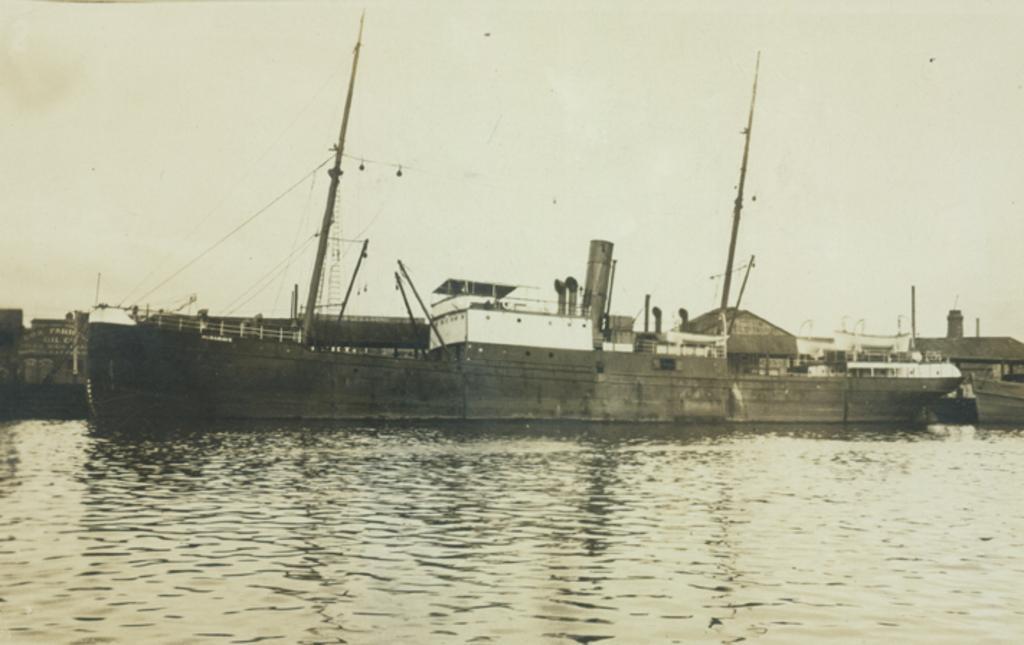Please provide a concise description of this image. In this image we can see the Clyde steamer in water. And we can see the sky. 